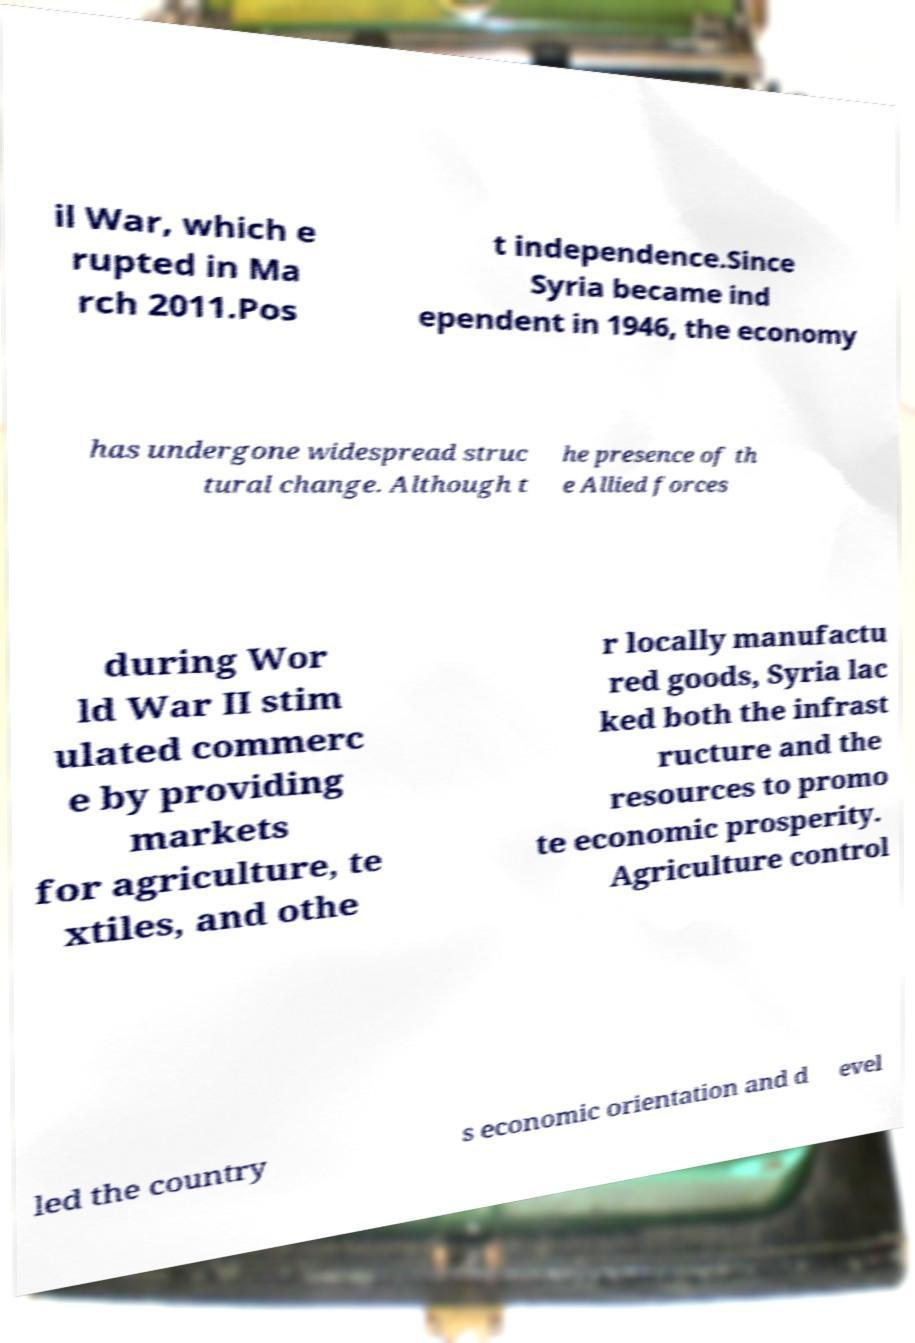Could you extract and type out the text from this image? il War, which e rupted in Ma rch 2011.Pos t independence.Since Syria became ind ependent in 1946, the economy has undergone widespread struc tural change. Although t he presence of th e Allied forces during Wor ld War II stim ulated commerc e by providing markets for agriculture, te xtiles, and othe r locally manufactu red goods, Syria lac ked both the infrast ructure and the resources to promo te economic prosperity. Agriculture control led the country s economic orientation and d evel 